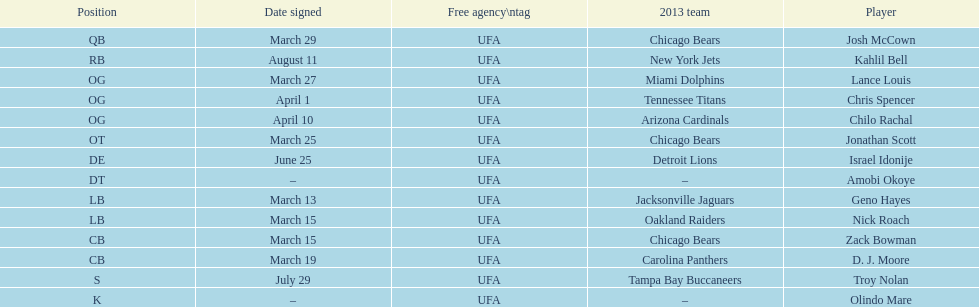Geno hayes and nick roach both played which position? LB. Could you parse the entire table? {'header': ['Position', 'Date signed', 'Free agency\\ntag', '2013 team', 'Player'], 'rows': [['QB', 'March 29', 'UFA', 'Chicago Bears', 'Josh McCown'], ['RB', 'August 11', 'UFA', 'New York Jets', 'Kahlil Bell'], ['OG', 'March 27', 'UFA', 'Miami Dolphins', 'Lance Louis'], ['OG', 'April 1', 'UFA', 'Tennessee Titans', 'Chris Spencer'], ['OG', 'April 10', 'UFA', 'Arizona Cardinals', 'Chilo Rachal'], ['OT', 'March 25', 'UFA', 'Chicago Bears', 'Jonathan Scott'], ['DE', 'June 25', 'UFA', 'Detroit Lions', 'Israel Idonije'], ['DT', '–', 'UFA', '–', 'Amobi Okoye'], ['LB', 'March 13', 'UFA', 'Jacksonville Jaguars', 'Geno Hayes'], ['LB', 'March 15', 'UFA', 'Oakland Raiders', 'Nick Roach'], ['CB', 'March 15', 'UFA', 'Chicago Bears', 'Zack Bowman'], ['CB', 'March 19', 'UFA', 'Carolina Panthers', 'D. J. Moore'], ['S', 'July 29', 'UFA', 'Tampa Bay Buccaneers', 'Troy Nolan'], ['K', '–', 'UFA', '–', 'Olindo Mare']]} 